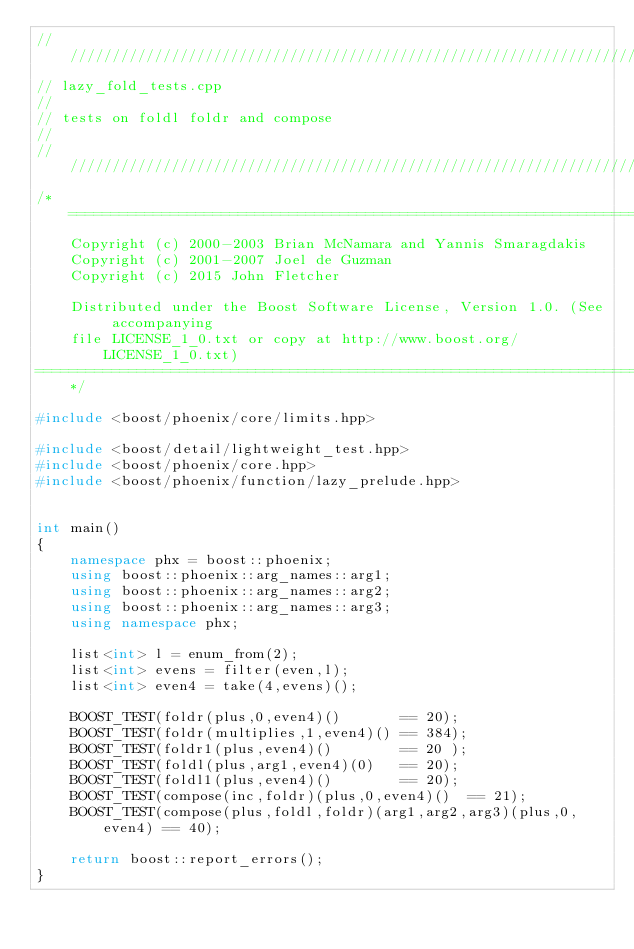Convert code to text. <code><loc_0><loc_0><loc_500><loc_500><_C++_>////////////////////////////////////////////////////////////////////////////
// lazy_fold_tests.cpp
//
// tests on foldl foldr and compose
//
////////////////////////////////////////////////////////////////////////////
/*=============================================================================
    Copyright (c) 2000-2003 Brian McNamara and Yannis Smaragdakis
    Copyright (c) 2001-2007 Joel de Guzman
    Copyright (c) 2015 John Fletcher

    Distributed under the Boost Software License, Version 1.0. (See accompanying
    file LICENSE_1_0.txt or copy at http://www.boost.org/LICENSE_1_0.txt)
==============================================================================*/

#include <boost/phoenix/core/limits.hpp>

#include <boost/detail/lightweight_test.hpp>
#include <boost/phoenix/core.hpp>
#include <boost/phoenix/function/lazy_prelude.hpp>


int main()
{
    namespace phx = boost::phoenix;
    using boost::phoenix::arg_names::arg1;
    using boost::phoenix::arg_names::arg2;
    using boost::phoenix::arg_names::arg3;
    using namespace phx;

    list<int> l = enum_from(2);
    list<int> evens = filter(even,l);
    list<int> even4 = take(4,evens)();

    BOOST_TEST(foldr(plus,0,even4)()       == 20);
    BOOST_TEST(foldr(multiplies,1,even4)() == 384);
    BOOST_TEST(foldr1(plus,even4)()        == 20 );
    BOOST_TEST(foldl(plus,arg1,even4)(0)   == 20);
    BOOST_TEST(foldl1(plus,even4)()        == 20);
    BOOST_TEST(compose(inc,foldr)(plus,0,even4)()  == 21);
    BOOST_TEST(compose(plus,foldl,foldr)(arg1,arg2,arg3)(plus,0,even4) == 40);
   
    return boost::report_errors();
}
</code> 